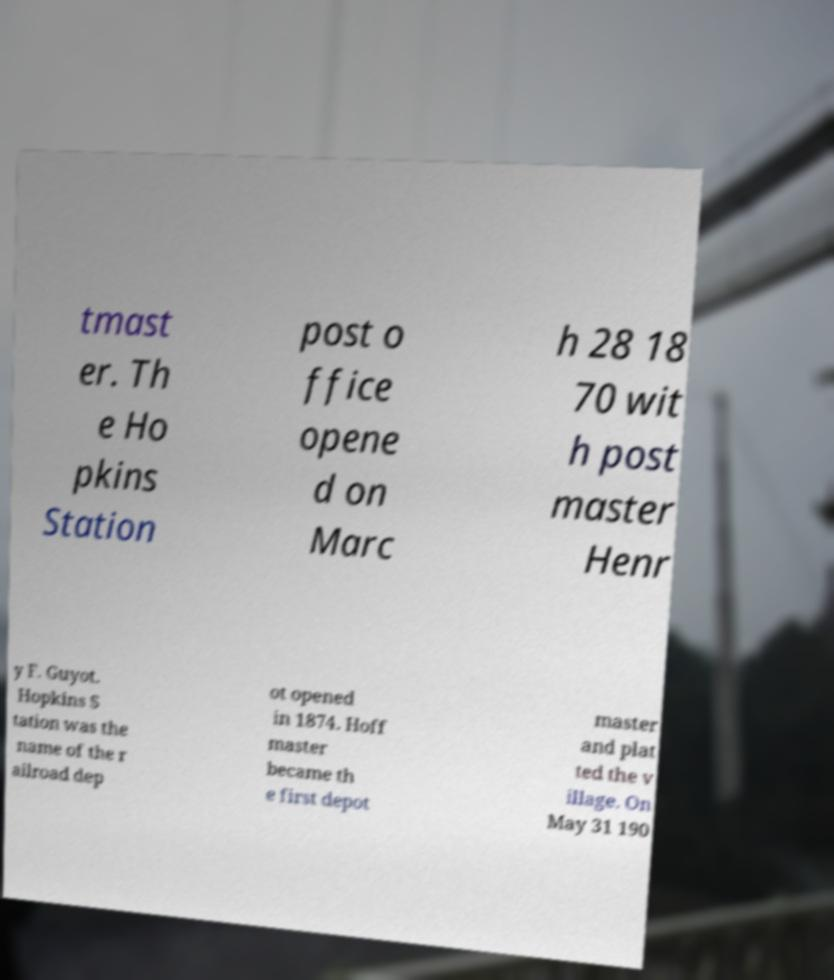Can you accurately transcribe the text from the provided image for me? tmast er. Th e Ho pkins Station post o ffice opene d on Marc h 28 18 70 wit h post master Henr y F. Guyot. Hopkins S tation was the name of the r ailroad dep ot opened in 1874. Hoff master became th e first depot master and plat ted the v illage. On May 31 190 